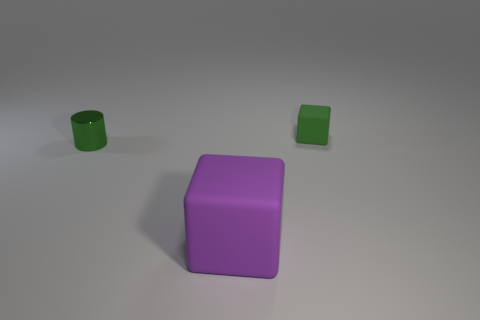Add 1 small yellow objects. How many objects exist? 4 Subtract all purple cubes. How many cubes are left? 1 Subtract all cyan matte blocks. Subtract all cylinders. How many objects are left? 2 Add 1 cubes. How many cubes are left? 3 Add 3 large blue metallic spheres. How many large blue metallic spheres exist? 3 Subtract 0 green balls. How many objects are left? 3 Subtract all cylinders. How many objects are left? 2 Subtract all green blocks. Subtract all red cylinders. How many blocks are left? 1 